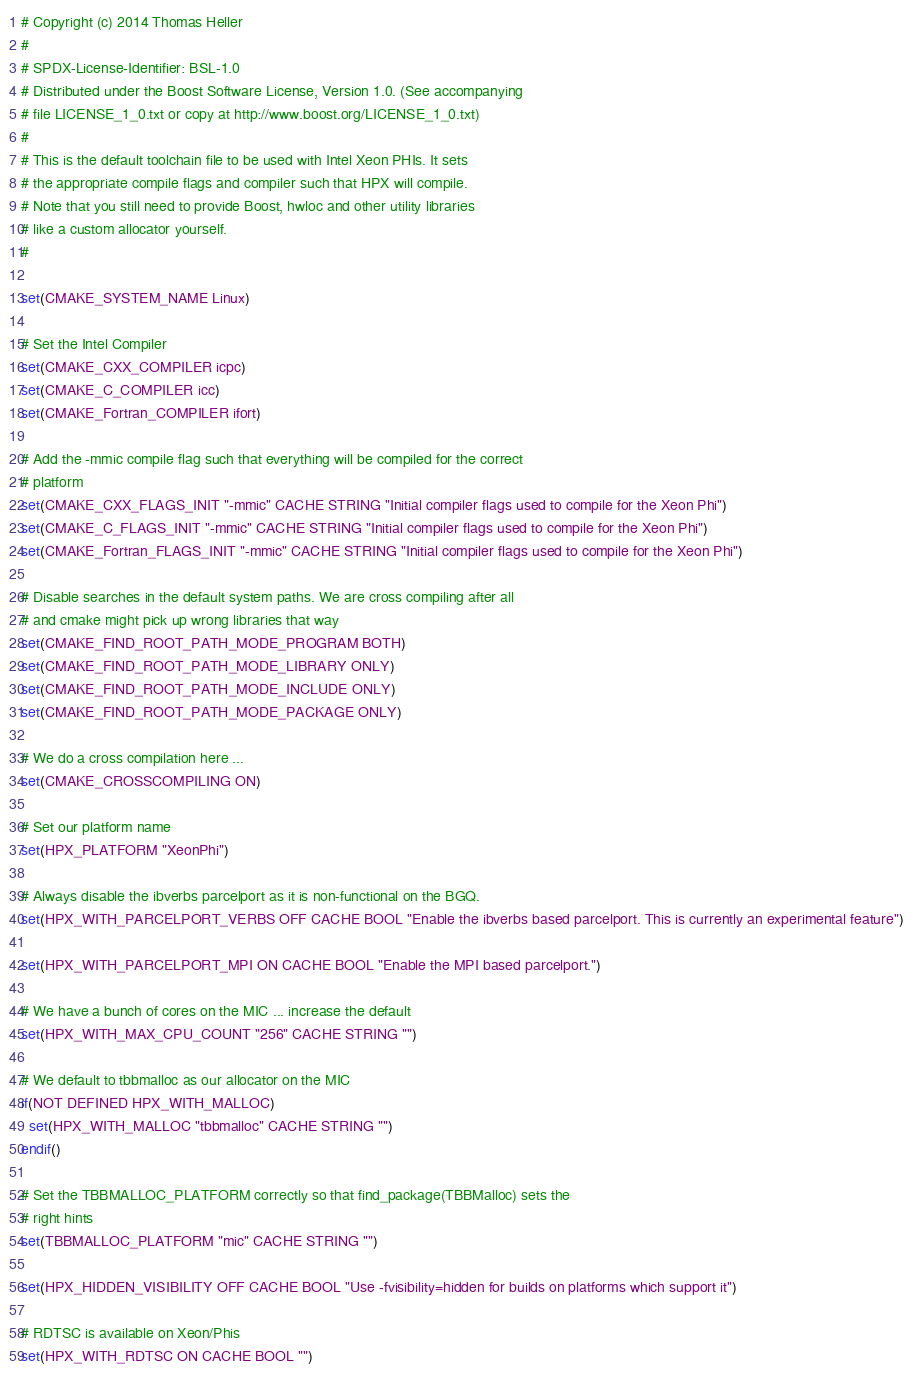Convert code to text. <code><loc_0><loc_0><loc_500><loc_500><_CMake_># Copyright (c) 2014 Thomas Heller
#
# SPDX-License-Identifier: BSL-1.0
# Distributed under the Boost Software License, Version 1.0. (See accompanying
# file LICENSE_1_0.txt or copy at http://www.boost.org/LICENSE_1_0.txt)
#
# This is the default toolchain file to be used with Intel Xeon PHIs. It sets
# the appropriate compile flags and compiler such that HPX will compile.
# Note that you still need to provide Boost, hwloc and other utility libraries
# like a custom allocator yourself.
#

set(CMAKE_SYSTEM_NAME Linux)

# Set the Intel Compiler
set(CMAKE_CXX_COMPILER icpc)
set(CMAKE_C_COMPILER icc)
set(CMAKE_Fortran_COMPILER ifort)

# Add the -mmic compile flag such that everything will be compiled for the correct
# platform
set(CMAKE_CXX_FLAGS_INIT "-mmic" CACHE STRING "Initial compiler flags used to compile for the Xeon Phi")
set(CMAKE_C_FLAGS_INIT "-mmic" CACHE STRING "Initial compiler flags used to compile for the Xeon Phi")
set(CMAKE_Fortran_FLAGS_INIT "-mmic" CACHE STRING "Initial compiler flags used to compile for the Xeon Phi")

# Disable searches in the default system paths. We are cross compiling after all
# and cmake might pick up wrong libraries that way
set(CMAKE_FIND_ROOT_PATH_MODE_PROGRAM BOTH)
set(CMAKE_FIND_ROOT_PATH_MODE_LIBRARY ONLY)
set(CMAKE_FIND_ROOT_PATH_MODE_INCLUDE ONLY)
set(CMAKE_FIND_ROOT_PATH_MODE_PACKAGE ONLY)

# We do a cross compilation here ...
set(CMAKE_CROSSCOMPILING ON)

# Set our platform name
set(HPX_PLATFORM "XeonPhi")

# Always disable the ibverbs parcelport as it is non-functional on the BGQ.
set(HPX_WITH_PARCELPORT_VERBS OFF CACHE BOOL "Enable the ibverbs based parcelport. This is currently an experimental feature")

set(HPX_WITH_PARCELPORT_MPI ON CACHE BOOL "Enable the MPI based parcelport.")

# We have a bunch of cores on the MIC ... increase the default
set(HPX_WITH_MAX_CPU_COUNT "256" CACHE STRING "")

# We default to tbbmalloc as our allocator on the MIC
if(NOT DEFINED HPX_WITH_MALLOC)
  set(HPX_WITH_MALLOC "tbbmalloc" CACHE STRING "")
endif()

# Set the TBBMALLOC_PLATFORM correctly so that find_package(TBBMalloc) sets the
# right hints
set(TBBMALLOC_PLATFORM "mic" CACHE STRING "")

set(HPX_HIDDEN_VISIBILITY OFF CACHE BOOL "Use -fvisibility=hidden for builds on platforms which support it")

# RDTSC is available on Xeon/Phis
set(HPX_WITH_RDTSC ON CACHE BOOL "")

</code> 